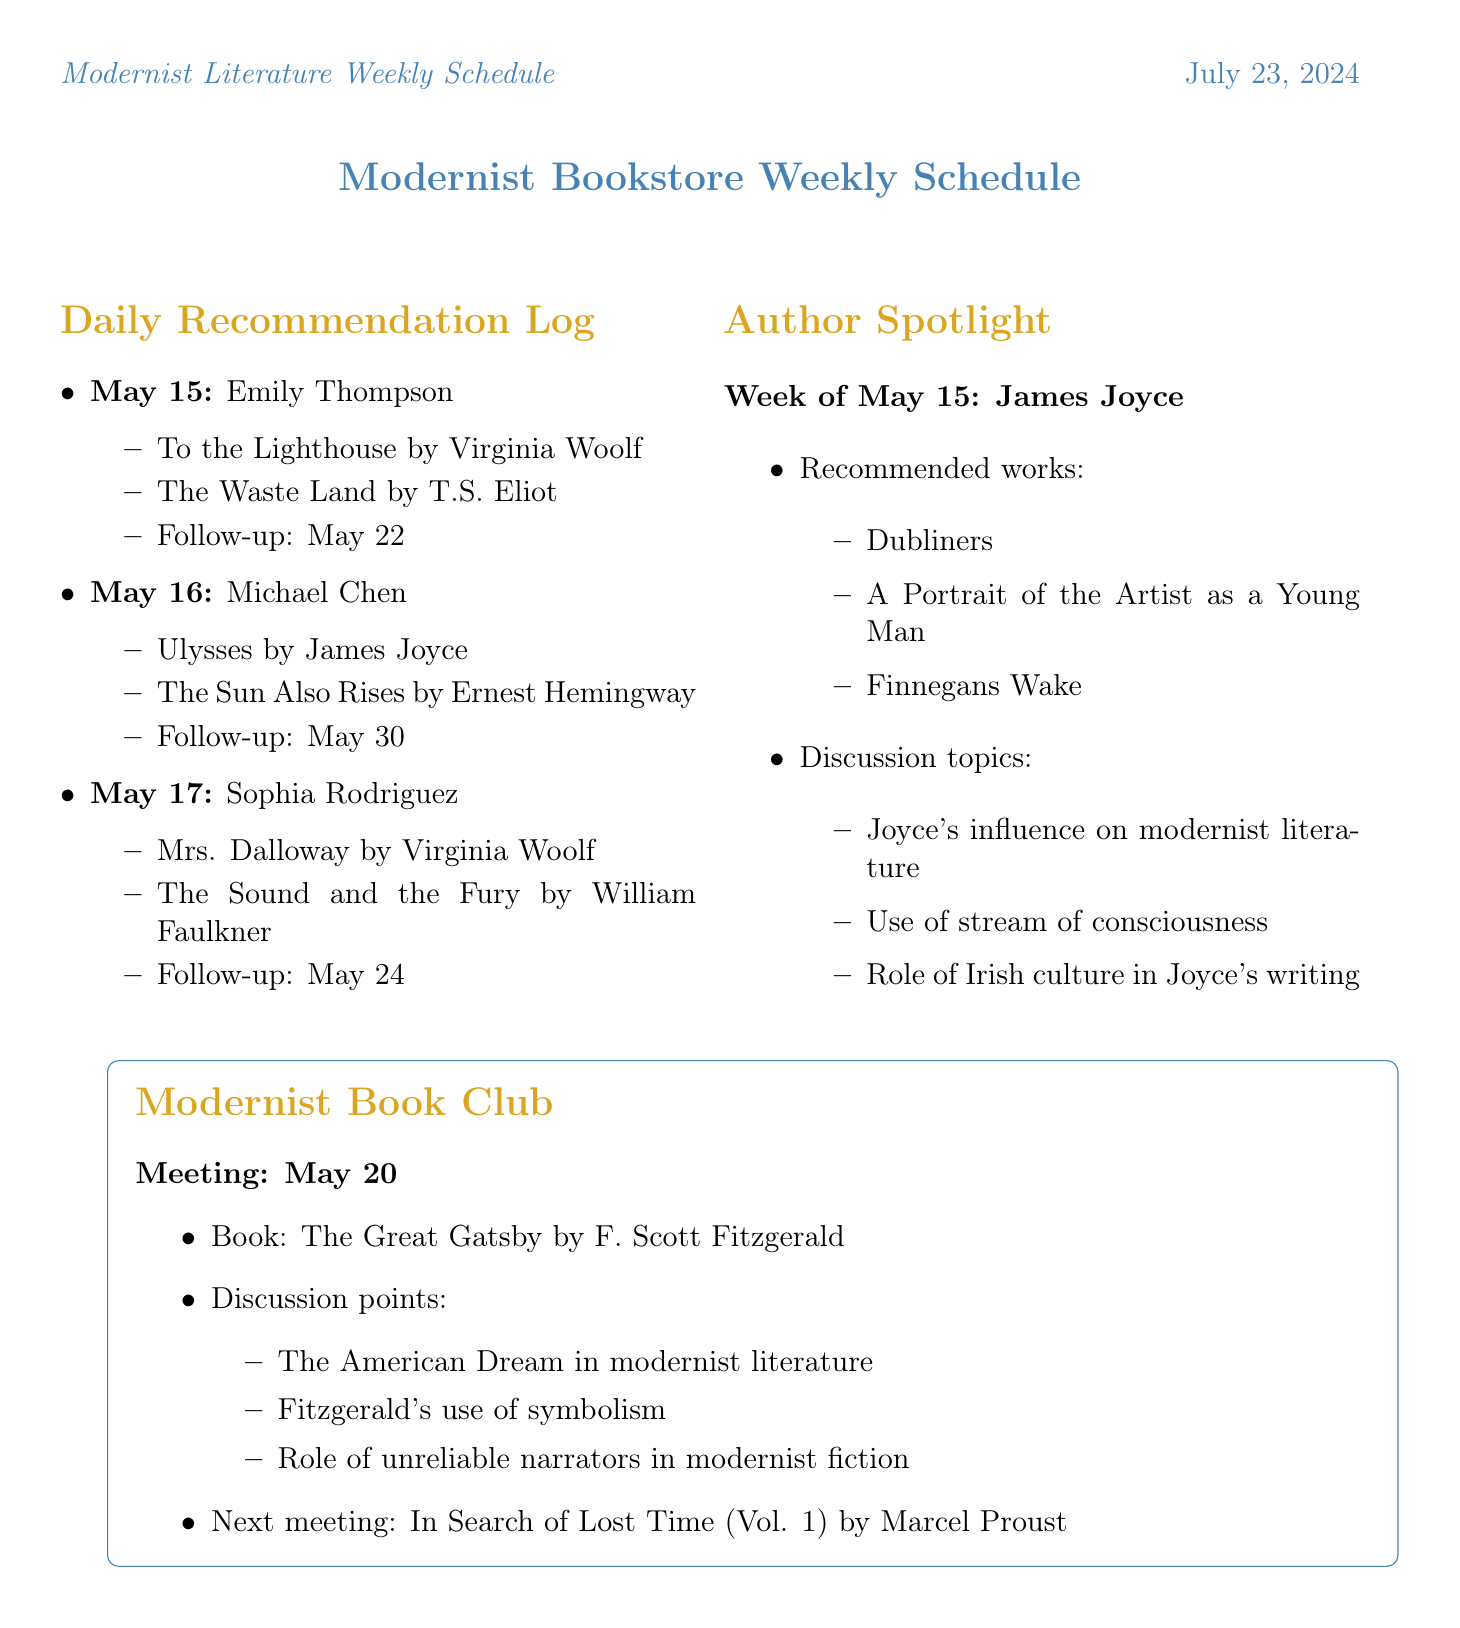What books were recommended to Emily Thompson? The recommended books for Emily Thompson are listed in the document under her entry for May 15.
Answer: To the Lighthouse, The Waste Land When is Michael Chen's follow-up appointment? The follow-up appointment is noted in the entry for Michael Chen under May 16.
Answer: May 30 What is the featured author for the week of May 15? The featured author is indicated in the Author Spotlight section for the designated week in the document.
Answer: James Joyce Which book will be discussed in the Modernist Book Club meeting on May 20? The book for discussion is stated in the Modernist Book Club section of the document.
Answer: The Great Gatsby What are two discussion topics for the upcoming Modernist Book Club meeting? The discussion points can be found in the same section for the Modernist Book Club meeting listed in the document.
Answer: The American Dream in modernist literature, Fitzgerald's use of symbolism What is the date of the Bloomsday Celebration event? The date of the Bloomsday Celebration is explicitly mentioned in the Upcoming Literary Events section of the document.
Answer: June 16, 2023 Name one of the featured poets in the Modernist Poetry Slam. Featured poets for the Modernist Poetry Slam event are listed under that event in the document.
Answer: Amanda Gorman What narrative style is Virginia Woolf known for, as reflected in the recommendations? The reason for recommending Woolf's books indicates a particular narrative style associated with her work in the document.
Answer: Stream of consciousness 